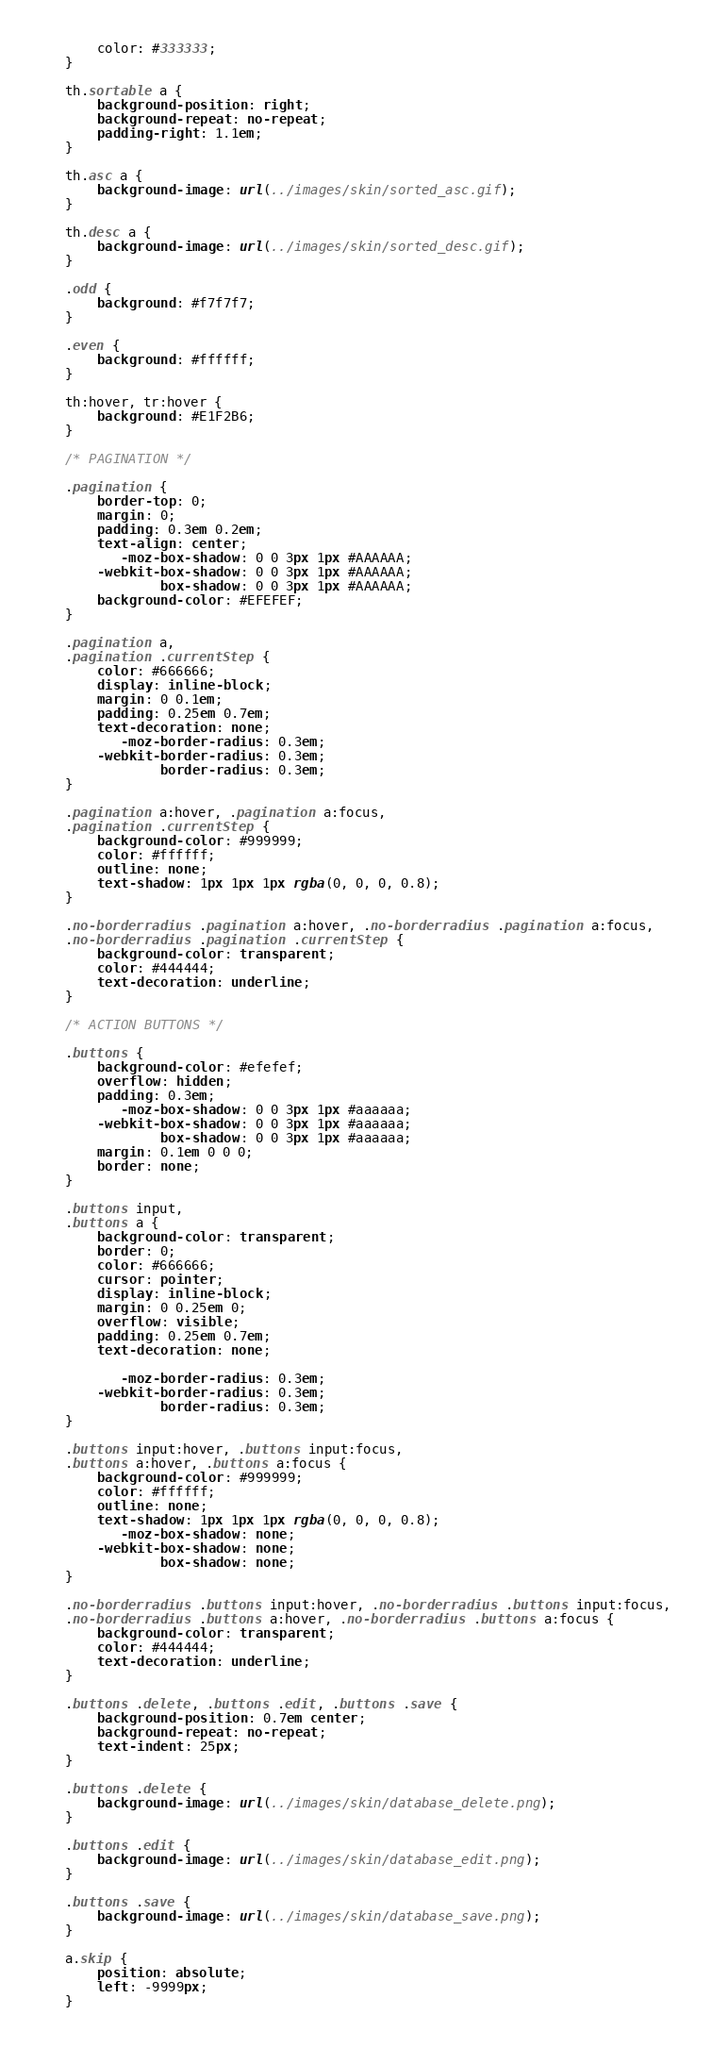<code> <loc_0><loc_0><loc_500><loc_500><_CSS_>    color: #333333;
}

th.sortable a {
    background-position: right;
    background-repeat: no-repeat;
    padding-right: 1.1em;
}

th.asc a {
    background-image: url(../images/skin/sorted_asc.gif);
}

th.desc a {
    background-image: url(../images/skin/sorted_desc.gif);
}

.odd {
    background: #f7f7f7;
}

.even {
    background: #ffffff;
}

th:hover, tr:hover {
    background: #E1F2B6;
}

/* PAGINATION */

.pagination {
    border-top: 0;
    margin: 0;
    padding: 0.3em 0.2em;
    text-align: center;
       -moz-box-shadow: 0 0 3px 1px #AAAAAA;
    -webkit-box-shadow: 0 0 3px 1px #AAAAAA;
            box-shadow: 0 0 3px 1px #AAAAAA;
    background-color: #EFEFEF;
}

.pagination a,
.pagination .currentStep {
    color: #666666;
    display: inline-block;
    margin: 0 0.1em;
    padding: 0.25em 0.7em;
    text-decoration: none;
       -moz-border-radius: 0.3em;
    -webkit-border-radius: 0.3em;
            border-radius: 0.3em;
}

.pagination a:hover, .pagination a:focus,
.pagination .currentStep {
    background-color: #999999;
    color: #ffffff;
    outline: none;
    text-shadow: 1px 1px 1px rgba(0, 0, 0, 0.8);
}

.no-borderradius .pagination a:hover, .no-borderradius .pagination a:focus,
.no-borderradius .pagination .currentStep {
    background-color: transparent;
    color: #444444;
    text-decoration: underline;
}

/* ACTION BUTTONS */

.buttons {
    background-color: #efefef;
    overflow: hidden;
    padding: 0.3em;
       -moz-box-shadow: 0 0 3px 1px #aaaaaa;
    -webkit-box-shadow: 0 0 3px 1px #aaaaaa;
            box-shadow: 0 0 3px 1px #aaaaaa;
    margin: 0.1em 0 0 0;
    border: none;
}

.buttons input,
.buttons a {
    background-color: transparent;
    border: 0;
    color: #666666;
    cursor: pointer;
    display: inline-block;
    margin: 0 0.25em 0;
    overflow: visible;
    padding: 0.25em 0.7em;
    text-decoration: none;

       -moz-border-radius: 0.3em;
    -webkit-border-radius: 0.3em;
            border-radius: 0.3em;
}

.buttons input:hover, .buttons input:focus,
.buttons a:hover, .buttons a:focus {
    background-color: #999999;
    color: #ffffff;
    outline: none;
    text-shadow: 1px 1px 1px rgba(0, 0, 0, 0.8);
       -moz-box-shadow: none;
    -webkit-box-shadow: none;
            box-shadow: none;
}

.no-borderradius .buttons input:hover, .no-borderradius .buttons input:focus,
.no-borderradius .buttons a:hover, .no-borderradius .buttons a:focus {
    background-color: transparent;
    color: #444444;
    text-decoration: underline;
}

.buttons .delete, .buttons .edit, .buttons .save {
    background-position: 0.7em center;
    background-repeat: no-repeat;
    text-indent: 25px;
}

.buttons .delete {
    background-image: url(../images/skin/database_delete.png);
}

.buttons .edit {
    background-image: url(../images/skin/database_edit.png);
}

.buttons .save {
    background-image: url(../images/skin/database_save.png);
}

a.skip {
    position: absolute;
    left: -9999px;
}
</code> 